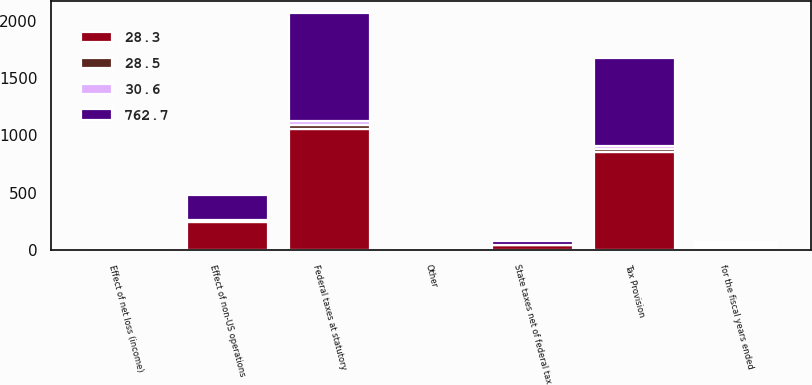Convert chart. <chart><loc_0><loc_0><loc_500><loc_500><stacked_bar_chart><ecel><fcel>for the fiscal years ended<fcel>Federal taxes at statutory<fcel>State taxes net of federal tax<fcel>Effect of non-US operations<fcel>Effect of net loss (income)<fcel>Other<fcel>Tax Provision<nl><fcel>28.3<fcel>18.25<fcel>1059.3<fcel>47.3<fcel>248<fcel>7.1<fcel>4.4<fcel>855.9<nl><fcel>28.5<fcel>18.25<fcel>35<fcel>1.6<fcel>8.2<fcel>0.2<fcel>0.1<fcel>28.3<nl><fcel>762.7<fcel>18.25<fcel>937.4<fcel>34.4<fcel>218.8<fcel>4.7<fcel>5<fcel>762.7<nl><fcel>30.6<fcel>18.25<fcel>35<fcel>1.3<fcel>8.2<fcel>0.2<fcel>0.2<fcel>28.5<nl></chart> 